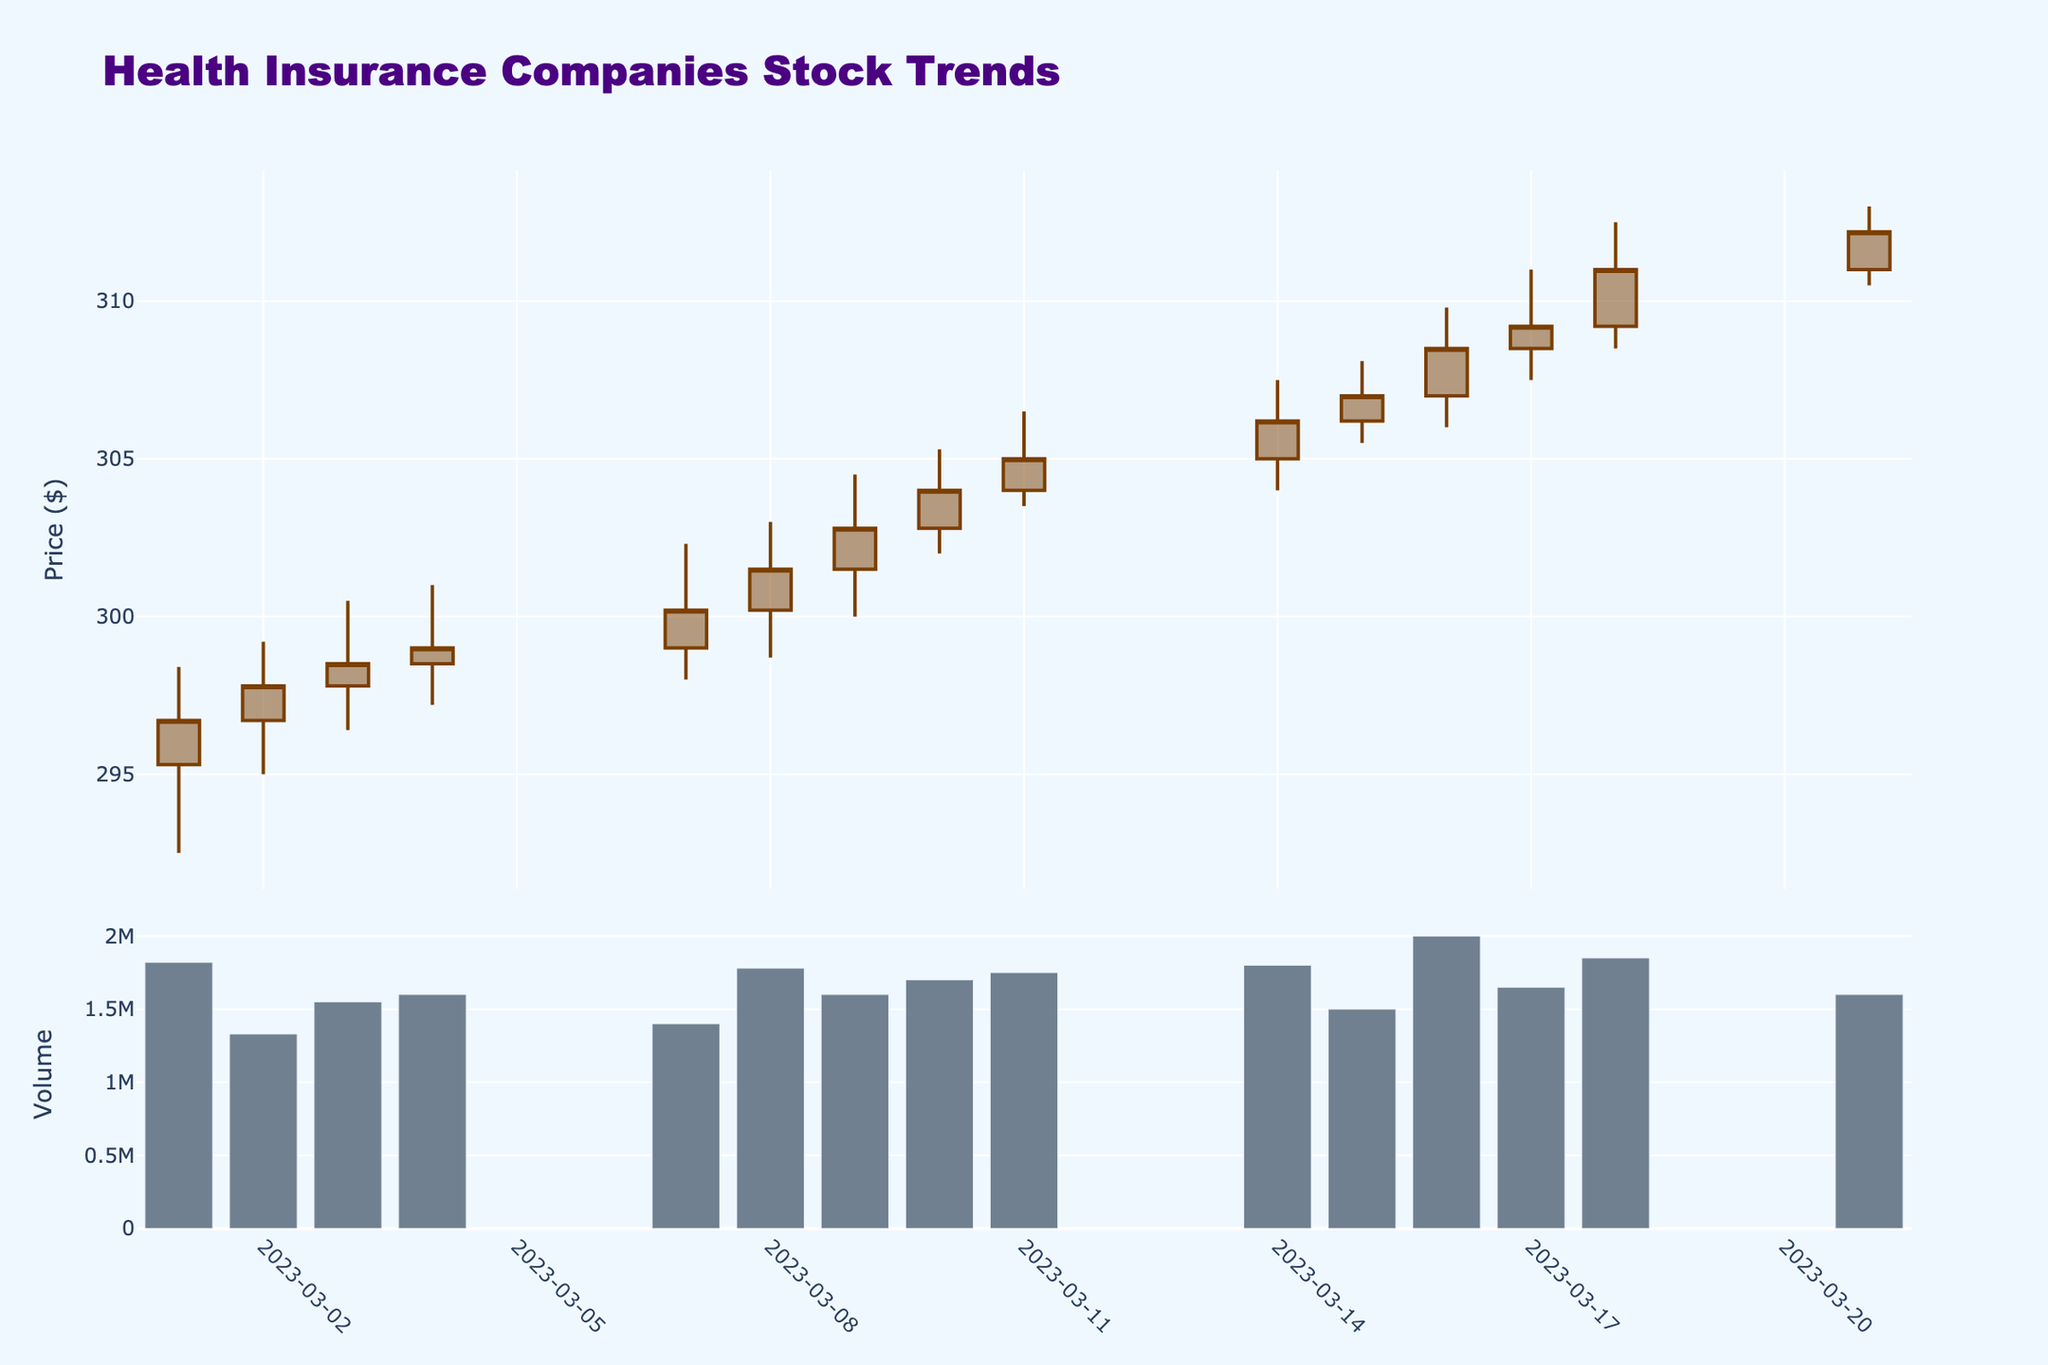What is the title of the figure? The title is prominently shown at the top of the figure.
Answer: Health Insurance Companies Stock Trends How many candlesticks are there in the candlestick plot? Each candlestick represents one trading day, and you can count them from the plot directly. There should be one candlestick for each row in the data provided.
Answer: 14 What is the closing price on March 10, 2023? Find the candlestick corresponding to March 10, 2023, and look for the closing price value.
Answer: 304.00 Which day had the highest trading volume? Look at the volume bars in the second row of the plot and identify the tallest bar, then find the corresponding date.
Answer: March 16, 2023 What is the highest stock price recorded in the provided data? Review the "High" points of the candlesticks to find the maximum value.
Answer: 313.00 Did the stock price generally trend upwards or downwards during the period shown in the plot? Compare the opening price on March 1, 2023, with the closing price on March 21, 2023. If the latter is higher, the trend is upwards.
Answer: Upwards What was the price change from the opening on March 1, 2023, to the closing on March 21, 2023? Subtract the opening price on March 1, 2023, from the closing price on March 21, 2023.
Answer: 312.20 - 295.30 = 16.90 Which date shows the largest single-day increase in closing price? Calculate the difference between each day's closing price and the previous day's closing price, then identify the largest positive difference.
Answer: March 17, 2023 (309.20 - 308.50 = 0.70) On which days did the lowest price of the day match the closing price of the previous day? Compare each day's "Low" price with the previous day's "Close" price.
Answer: March 2, 2023; March 4, 2023; March 8, 2023 What is the average closing price for the period shown in the plot? Sum all closing prices and divide by the number of closing prices (14).
Answer: (296.70 + 297.80 + 298.50 + 299.00 + 300.20 + 301.50 + 302.80 + 304.00 + 305.00 + 306.20 + 307.00 + 308.50 + 309.20 + 311.00 + 312.20)/14 ≈ 303.86 